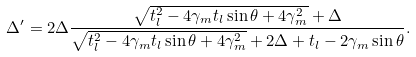<formula> <loc_0><loc_0><loc_500><loc_500>\Delta ^ { \prime } = 2 \Delta \frac { \sqrt { t _ { l } ^ { 2 } - 4 \gamma _ { m } t _ { l } \sin \theta + 4 \gamma _ { m } ^ { 2 } } + \Delta } { \sqrt { t _ { l } ^ { 2 } - 4 \gamma _ { m } t _ { l } \sin \theta + 4 \gamma _ { m } ^ { 2 } } + 2 \Delta + t _ { l } - 2 \gamma _ { m } \sin \theta } .</formula> 